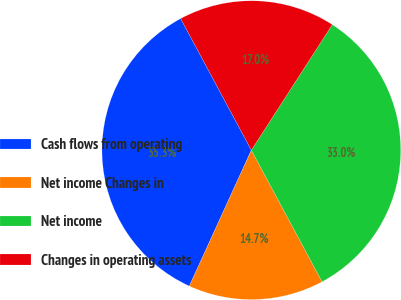<chart> <loc_0><loc_0><loc_500><loc_500><pie_chart><fcel>Cash flows from operating<fcel>Net income Changes in<fcel>Net income<fcel>Changes in operating assets<nl><fcel>35.34%<fcel>14.66%<fcel>33.04%<fcel>16.96%<nl></chart> 